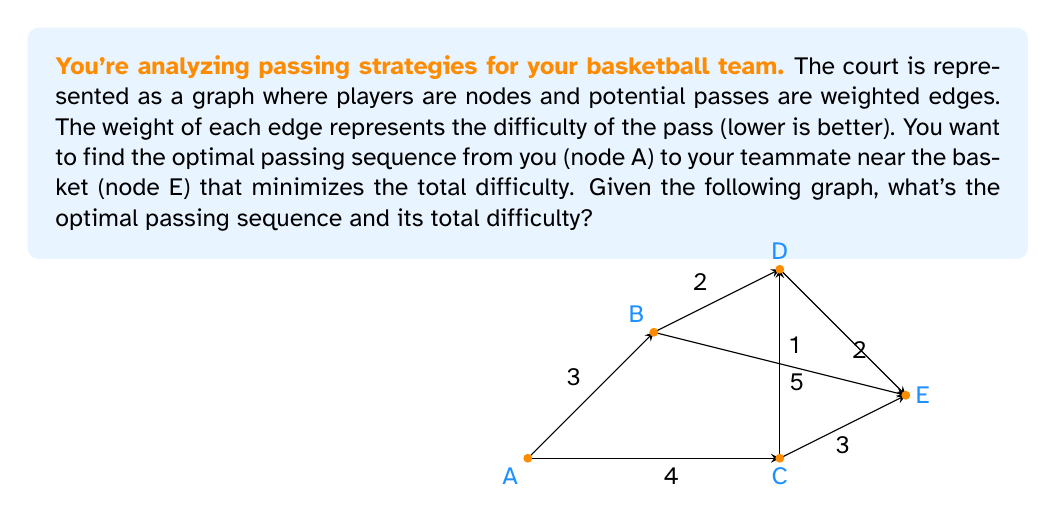Teach me how to tackle this problem. To solve this problem, we'll use Dijkstra's algorithm, which is perfect for finding the shortest path in a weighted graph. Here's how we apply it to our basketball passing scenario:

1) Initialize:
   - Set A's distance to 0 and all others to infinity.
   - Mark all nodes as unvisited.

2) For the current node (starting with A), consider all unvisited neighbors and calculate their tentative distances.
   - From A: B(3), C(4)

3) Mark the current node as visited. A is now visited.

4) Select the unvisited node with the smallest tentative distance as the new current node.
   - B is selected (distance 3)

5) Repeat steps 2-4:
   - From B: D(3+2=5), E(3+5=8)
   - B is visited
   - C is selected (distance 4)
   - From C: D(4+1=5), E(4+3=7)
   - C is visited
   - D is selected (distance 5)
   - From D: E(5+2=7)
   - D is visited
   - E is selected (distance 7)

6) The algorithm ends as we've reached our target node E.

The optimal path is A → C → E with a total difficulty of 7.

This path represents you passing to the player at C, who then passes to the player near the basket at E. The total difficulty (7) is the sum of the weights along this path (4 + 3).
Answer: Optimal passing sequence: A → C → E
Total difficulty: 7 